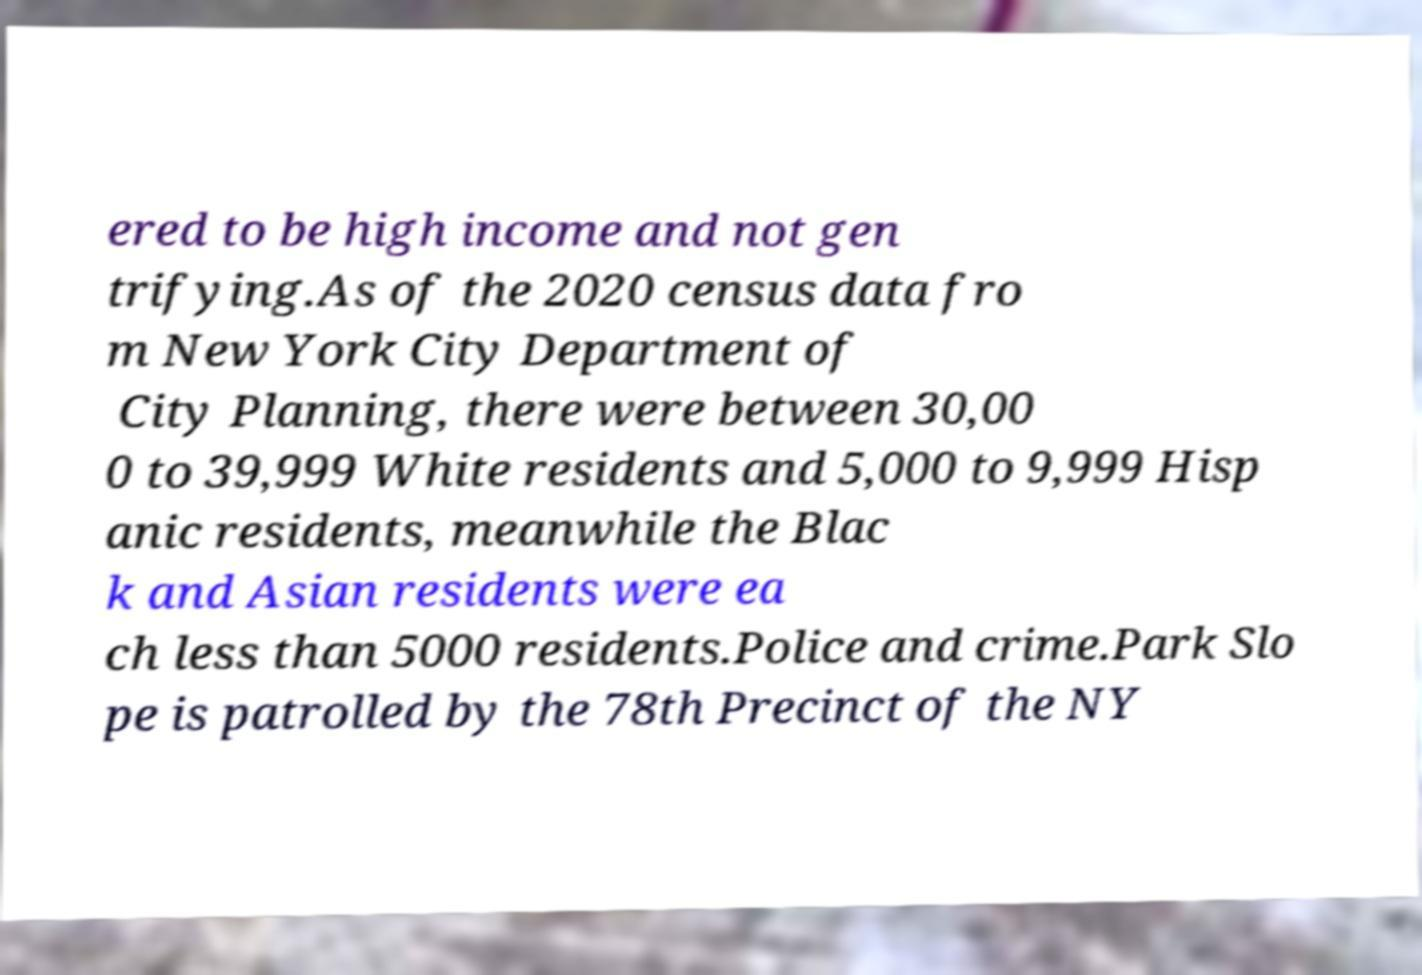Could you assist in decoding the text presented in this image and type it out clearly? ered to be high income and not gen trifying.As of the 2020 census data fro m New York City Department of City Planning, there were between 30,00 0 to 39,999 White residents and 5,000 to 9,999 Hisp anic residents, meanwhile the Blac k and Asian residents were ea ch less than 5000 residents.Police and crime.Park Slo pe is patrolled by the 78th Precinct of the NY 